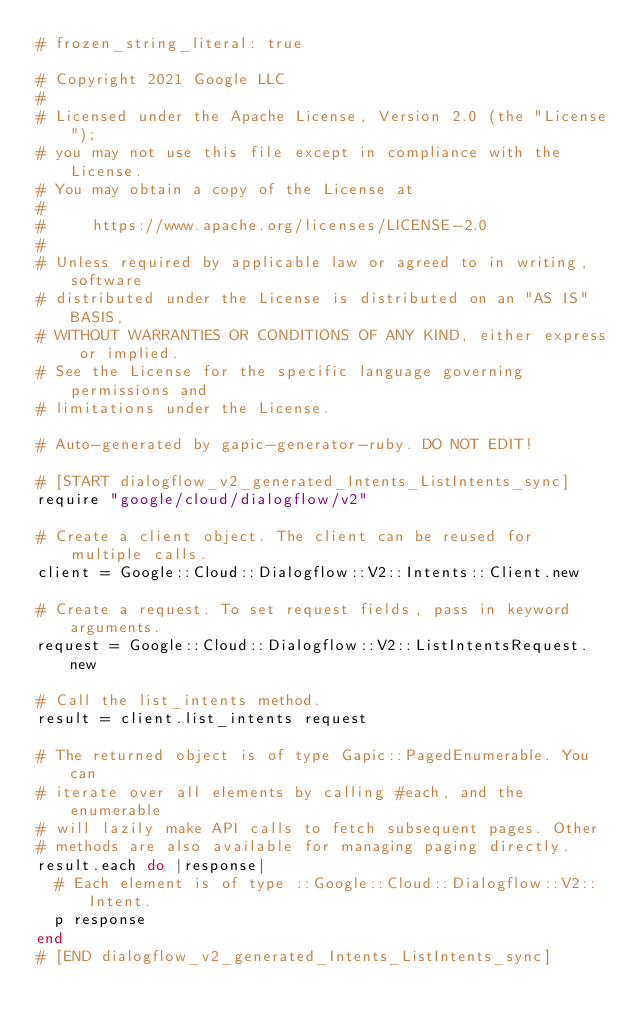Convert code to text. <code><loc_0><loc_0><loc_500><loc_500><_Ruby_># frozen_string_literal: true

# Copyright 2021 Google LLC
#
# Licensed under the Apache License, Version 2.0 (the "License");
# you may not use this file except in compliance with the License.
# You may obtain a copy of the License at
#
#     https://www.apache.org/licenses/LICENSE-2.0
#
# Unless required by applicable law or agreed to in writing, software
# distributed under the License is distributed on an "AS IS" BASIS,
# WITHOUT WARRANTIES OR CONDITIONS OF ANY KIND, either express or implied.
# See the License for the specific language governing permissions and
# limitations under the License.

# Auto-generated by gapic-generator-ruby. DO NOT EDIT!

# [START dialogflow_v2_generated_Intents_ListIntents_sync]
require "google/cloud/dialogflow/v2"

# Create a client object. The client can be reused for multiple calls.
client = Google::Cloud::Dialogflow::V2::Intents::Client.new

# Create a request. To set request fields, pass in keyword arguments.
request = Google::Cloud::Dialogflow::V2::ListIntentsRequest.new

# Call the list_intents method.
result = client.list_intents request

# The returned object is of type Gapic::PagedEnumerable. You can
# iterate over all elements by calling #each, and the enumerable
# will lazily make API calls to fetch subsequent pages. Other
# methods are also available for managing paging directly.
result.each do |response|
  # Each element is of type ::Google::Cloud::Dialogflow::V2::Intent.
  p response
end
# [END dialogflow_v2_generated_Intents_ListIntents_sync]
</code> 